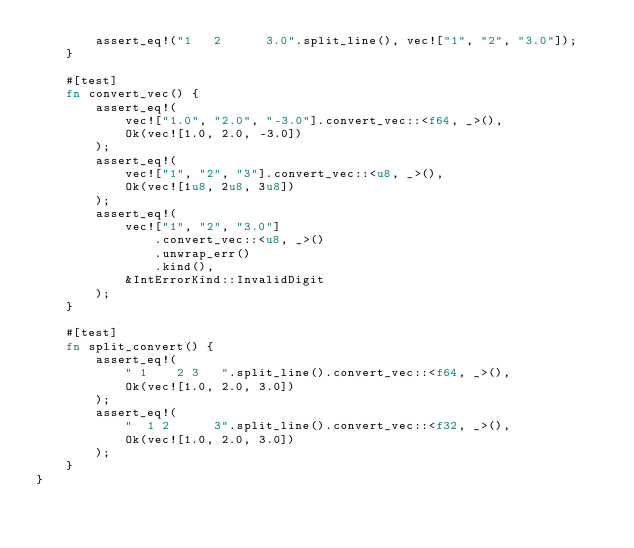Convert code to text. <code><loc_0><loc_0><loc_500><loc_500><_Rust_>        assert_eq!("1   2      3.0".split_line(), vec!["1", "2", "3.0"]);
    }

    #[test]
    fn convert_vec() {
        assert_eq!(
            vec!["1.0", "2.0", "-3.0"].convert_vec::<f64, _>(),
            Ok(vec![1.0, 2.0, -3.0])
        );
        assert_eq!(
            vec!["1", "2", "3"].convert_vec::<u8, _>(),
            Ok(vec![1u8, 2u8, 3u8])
        );
        assert_eq!(
            vec!["1", "2", "3.0"]
                .convert_vec::<u8, _>()
                .unwrap_err()
                .kind(),
            &IntErrorKind::InvalidDigit
        );
    }

    #[test]
    fn split_convert() {
        assert_eq!(
            " 1    2 3   ".split_line().convert_vec::<f64, _>(),
            Ok(vec![1.0, 2.0, 3.0])
        );
        assert_eq!(
            "  1 2    	3".split_line().convert_vec::<f32, _>(),
            Ok(vec![1.0, 2.0, 3.0])
        );
    }
}
</code> 